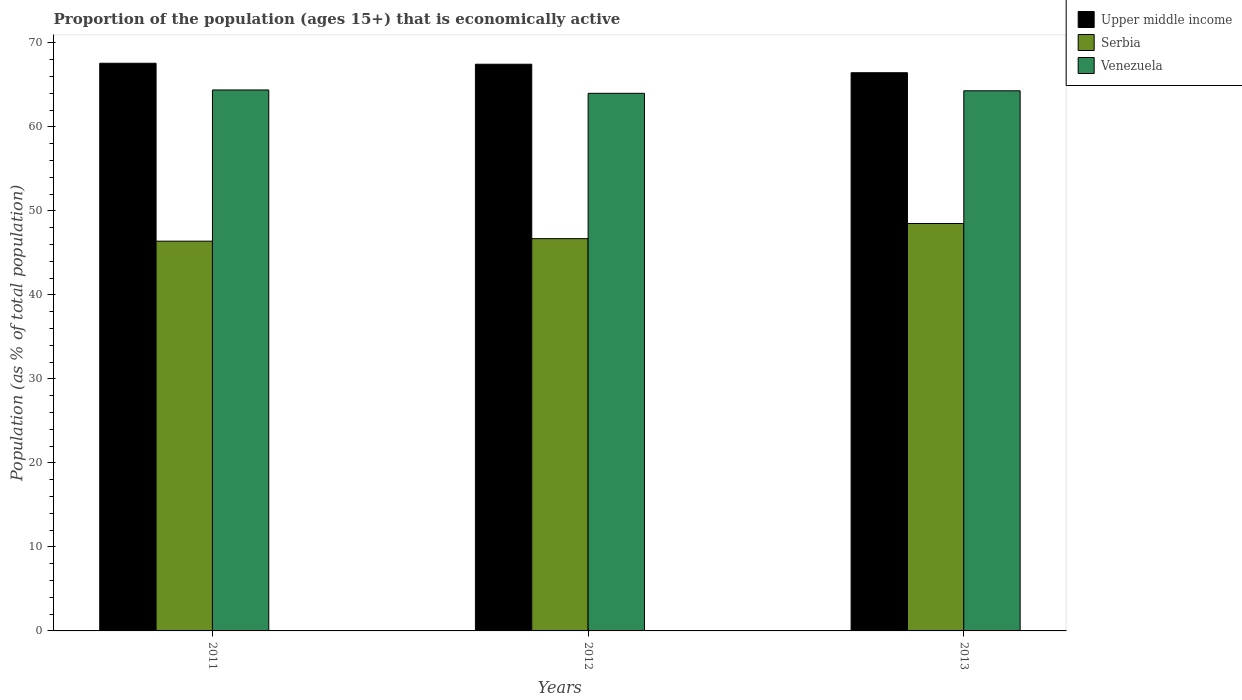Are the number of bars on each tick of the X-axis equal?
Your answer should be very brief. Yes. How many bars are there on the 2nd tick from the left?
Your response must be concise. 3. How many bars are there on the 2nd tick from the right?
Provide a short and direct response. 3. What is the label of the 2nd group of bars from the left?
Ensure brevity in your answer.  2012. What is the proportion of the population that is economically active in Venezuela in 2011?
Ensure brevity in your answer.  64.4. Across all years, what is the maximum proportion of the population that is economically active in Upper middle income?
Provide a succinct answer. 67.58. Across all years, what is the minimum proportion of the population that is economically active in Upper middle income?
Provide a succinct answer. 66.45. In which year was the proportion of the population that is economically active in Venezuela minimum?
Give a very brief answer. 2012. What is the total proportion of the population that is economically active in Upper middle income in the graph?
Your answer should be very brief. 201.5. What is the difference between the proportion of the population that is economically active in Upper middle income in 2011 and that in 2012?
Give a very brief answer. 0.12. What is the difference between the proportion of the population that is economically active in Serbia in 2011 and the proportion of the population that is economically active in Upper middle income in 2012?
Make the answer very short. -21.06. What is the average proportion of the population that is economically active in Serbia per year?
Provide a short and direct response. 47.2. In the year 2012, what is the difference between the proportion of the population that is economically active in Upper middle income and proportion of the population that is economically active in Venezuela?
Your answer should be compact. 3.46. In how many years, is the proportion of the population that is economically active in Upper middle income greater than 18 %?
Provide a short and direct response. 3. What is the ratio of the proportion of the population that is economically active in Venezuela in 2011 to that in 2013?
Ensure brevity in your answer.  1. Is the proportion of the population that is economically active in Serbia in 2011 less than that in 2013?
Provide a succinct answer. Yes. What is the difference between the highest and the second highest proportion of the population that is economically active in Serbia?
Your answer should be very brief. 1.8. What is the difference between the highest and the lowest proportion of the population that is economically active in Venezuela?
Ensure brevity in your answer.  0.4. Is the sum of the proportion of the population that is economically active in Venezuela in 2011 and 2013 greater than the maximum proportion of the population that is economically active in Upper middle income across all years?
Your answer should be very brief. Yes. What does the 2nd bar from the left in 2011 represents?
Ensure brevity in your answer.  Serbia. What does the 3rd bar from the right in 2011 represents?
Keep it short and to the point. Upper middle income. How many bars are there?
Offer a very short reply. 9. Are all the bars in the graph horizontal?
Offer a terse response. No. Are the values on the major ticks of Y-axis written in scientific E-notation?
Offer a very short reply. No. Where does the legend appear in the graph?
Provide a succinct answer. Top right. How are the legend labels stacked?
Your answer should be very brief. Vertical. What is the title of the graph?
Your answer should be very brief. Proportion of the population (ages 15+) that is economically active. Does "Caribbean small states" appear as one of the legend labels in the graph?
Ensure brevity in your answer.  No. What is the label or title of the X-axis?
Provide a succinct answer. Years. What is the label or title of the Y-axis?
Keep it short and to the point. Population (as % of total population). What is the Population (as % of total population) in Upper middle income in 2011?
Make the answer very short. 67.58. What is the Population (as % of total population) in Serbia in 2011?
Provide a succinct answer. 46.4. What is the Population (as % of total population) in Venezuela in 2011?
Give a very brief answer. 64.4. What is the Population (as % of total population) in Upper middle income in 2012?
Your answer should be very brief. 67.46. What is the Population (as % of total population) in Serbia in 2012?
Provide a short and direct response. 46.7. What is the Population (as % of total population) of Upper middle income in 2013?
Ensure brevity in your answer.  66.45. What is the Population (as % of total population) of Serbia in 2013?
Give a very brief answer. 48.5. What is the Population (as % of total population) of Venezuela in 2013?
Provide a succinct answer. 64.3. Across all years, what is the maximum Population (as % of total population) of Upper middle income?
Offer a terse response. 67.58. Across all years, what is the maximum Population (as % of total population) of Serbia?
Offer a very short reply. 48.5. Across all years, what is the maximum Population (as % of total population) in Venezuela?
Make the answer very short. 64.4. Across all years, what is the minimum Population (as % of total population) of Upper middle income?
Keep it short and to the point. 66.45. Across all years, what is the minimum Population (as % of total population) of Serbia?
Provide a succinct answer. 46.4. Across all years, what is the minimum Population (as % of total population) in Venezuela?
Provide a short and direct response. 64. What is the total Population (as % of total population) of Upper middle income in the graph?
Your answer should be very brief. 201.5. What is the total Population (as % of total population) in Serbia in the graph?
Offer a very short reply. 141.6. What is the total Population (as % of total population) of Venezuela in the graph?
Keep it short and to the point. 192.7. What is the difference between the Population (as % of total population) in Upper middle income in 2011 and that in 2012?
Offer a very short reply. 0.12. What is the difference between the Population (as % of total population) in Upper middle income in 2011 and that in 2013?
Give a very brief answer. 1.13. What is the difference between the Population (as % of total population) of Upper middle income in 2012 and that in 2013?
Provide a succinct answer. 1.01. What is the difference between the Population (as % of total population) of Venezuela in 2012 and that in 2013?
Your answer should be very brief. -0.3. What is the difference between the Population (as % of total population) of Upper middle income in 2011 and the Population (as % of total population) of Serbia in 2012?
Your response must be concise. 20.88. What is the difference between the Population (as % of total population) in Upper middle income in 2011 and the Population (as % of total population) in Venezuela in 2012?
Your answer should be very brief. 3.58. What is the difference between the Population (as % of total population) of Serbia in 2011 and the Population (as % of total population) of Venezuela in 2012?
Give a very brief answer. -17.6. What is the difference between the Population (as % of total population) of Upper middle income in 2011 and the Population (as % of total population) of Serbia in 2013?
Your response must be concise. 19.08. What is the difference between the Population (as % of total population) in Upper middle income in 2011 and the Population (as % of total population) in Venezuela in 2013?
Your response must be concise. 3.28. What is the difference between the Population (as % of total population) in Serbia in 2011 and the Population (as % of total population) in Venezuela in 2013?
Keep it short and to the point. -17.9. What is the difference between the Population (as % of total population) of Upper middle income in 2012 and the Population (as % of total population) of Serbia in 2013?
Provide a succinct answer. 18.96. What is the difference between the Population (as % of total population) in Upper middle income in 2012 and the Population (as % of total population) in Venezuela in 2013?
Your answer should be compact. 3.16. What is the difference between the Population (as % of total population) in Serbia in 2012 and the Population (as % of total population) in Venezuela in 2013?
Provide a short and direct response. -17.6. What is the average Population (as % of total population) in Upper middle income per year?
Give a very brief answer. 67.17. What is the average Population (as % of total population) in Serbia per year?
Offer a terse response. 47.2. What is the average Population (as % of total population) of Venezuela per year?
Ensure brevity in your answer.  64.23. In the year 2011, what is the difference between the Population (as % of total population) of Upper middle income and Population (as % of total population) of Serbia?
Offer a terse response. 21.18. In the year 2011, what is the difference between the Population (as % of total population) of Upper middle income and Population (as % of total population) of Venezuela?
Your response must be concise. 3.18. In the year 2011, what is the difference between the Population (as % of total population) in Serbia and Population (as % of total population) in Venezuela?
Provide a short and direct response. -18. In the year 2012, what is the difference between the Population (as % of total population) in Upper middle income and Population (as % of total population) in Serbia?
Keep it short and to the point. 20.76. In the year 2012, what is the difference between the Population (as % of total population) in Upper middle income and Population (as % of total population) in Venezuela?
Offer a very short reply. 3.46. In the year 2012, what is the difference between the Population (as % of total population) in Serbia and Population (as % of total population) in Venezuela?
Offer a very short reply. -17.3. In the year 2013, what is the difference between the Population (as % of total population) in Upper middle income and Population (as % of total population) in Serbia?
Your answer should be compact. 17.95. In the year 2013, what is the difference between the Population (as % of total population) in Upper middle income and Population (as % of total population) in Venezuela?
Give a very brief answer. 2.15. In the year 2013, what is the difference between the Population (as % of total population) in Serbia and Population (as % of total population) in Venezuela?
Make the answer very short. -15.8. What is the ratio of the Population (as % of total population) of Serbia in 2011 to that in 2012?
Provide a short and direct response. 0.99. What is the ratio of the Population (as % of total population) in Serbia in 2011 to that in 2013?
Your answer should be very brief. 0.96. What is the ratio of the Population (as % of total population) in Upper middle income in 2012 to that in 2013?
Your response must be concise. 1.02. What is the ratio of the Population (as % of total population) in Serbia in 2012 to that in 2013?
Ensure brevity in your answer.  0.96. What is the difference between the highest and the second highest Population (as % of total population) in Upper middle income?
Give a very brief answer. 0.12. What is the difference between the highest and the second highest Population (as % of total population) in Serbia?
Give a very brief answer. 1.8. What is the difference between the highest and the lowest Population (as % of total population) in Upper middle income?
Offer a very short reply. 1.13. What is the difference between the highest and the lowest Population (as % of total population) in Serbia?
Give a very brief answer. 2.1. 